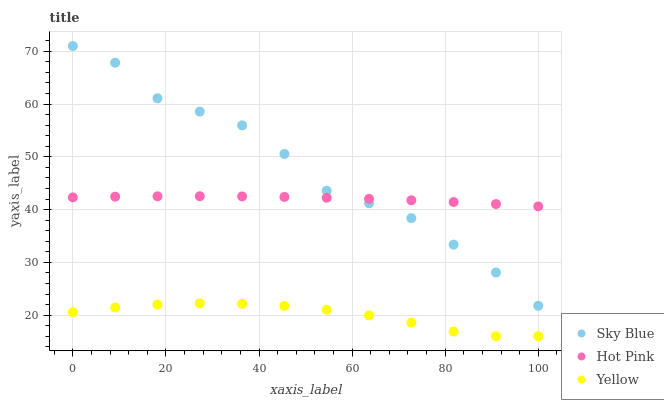Does Yellow have the minimum area under the curve?
Answer yes or no. Yes. Does Sky Blue have the maximum area under the curve?
Answer yes or no. Yes. Does Hot Pink have the minimum area under the curve?
Answer yes or no. No. Does Hot Pink have the maximum area under the curve?
Answer yes or no. No. Is Hot Pink the smoothest?
Answer yes or no. Yes. Is Sky Blue the roughest?
Answer yes or no. Yes. Is Yellow the smoothest?
Answer yes or no. No. Is Yellow the roughest?
Answer yes or no. No. Does Yellow have the lowest value?
Answer yes or no. Yes. Does Hot Pink have the lowest value?
Answer yes or no. No. Does Sky Blue have the highest value?
Answer yes or no. Yes. Does Hot Pink have the highest value?
Answer yes or no. No. Is Yellow less than Hot Pink?
Answer yes or no. Yes. Is Hot Pink greater than Yellow?
Answer yes or no. Yes. Does Sky Blue intersect Hot Pink?
Answer yes or no. Yes. Is Sky Blue less than Hot Pink?
Answer yes or no. No. Is Sky Blue greater than Hot Pink?
Answer yes or no. No. Does Yellow intersect Hot Pink?
Answer yes or no. No. 